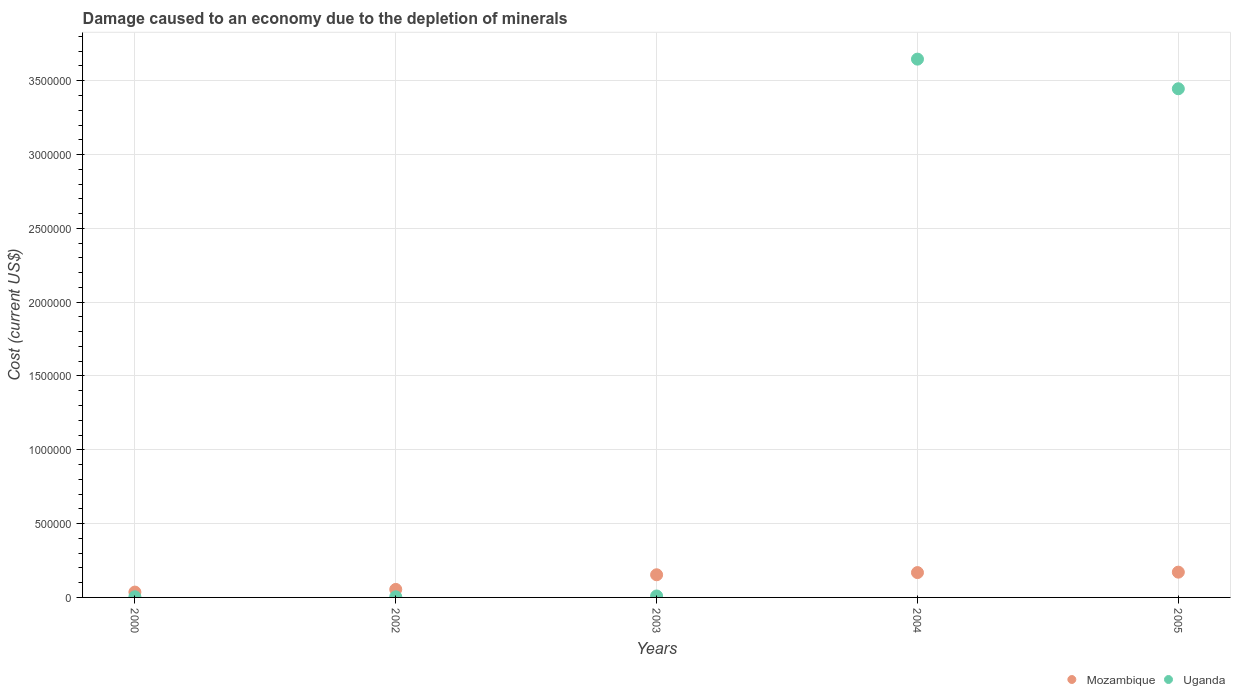Is the number of dotlines equal to the number of legend labels?
Ensure brevity in your answer.  Yes. What is the cost of damage caused due to the depletion of minerals in Uganda in 2005?
Give a very brief answer. 3.45e+06. Across all years, what is the maximum cost of damage caused due to the depletion of minerals in Uganda?
Ensure brevity in your answer.  3.65e+06. Across all years, what is the minimum cost of damage caused due to the depletion of minerals in Uganda?
Give a very brief answer. 4439.92. In which year was the cost of damage caused due to the depletion of minerals in Uganda minimum?
Offer a very short reply. 2002. What is the total cost of damage caused due to the depletion of minerals in Mozambique in the graph?
Offer a terse response. 5.83e+05. What is the difference between the cost of damage caused due to the depletion of minerals in Uganda in 2002 and that in 2005?
Offer a very short reply. -3.44e+06. What is the difference between the cost of damage caused due to the depletion of minerals in Mozambique in 2004 and the cost of damage caused due to the depletion of minerals in Uganda in 2000?
Make the answer very short. 1.64e+05. What is the average cost of damage caused due to the depletion of minerals in Mozambique per year?
Offer a very short reply. 1.17e+05. In the year 2002, what is the difference between the cost of damage caused due to the depletion of minerals in Mozambique and cost of damage caused due to the depletion of minerals in Uganda?
Provide a short and direct response. 4.99e+04. In how many years, is the cost of damage caused due to the depletion of minerals in Uganda greater than 2000000 US$?
Ensure brevity in your answer.  2. What is the ratio of the cost of damage caused due to the depletion of minerals in Mozambique in 2003 to that in 2005?
Offer a very short reply. 0.9. Is the difference between the cost of damage caused due to the depletion of minerals in Mozambique in 2000 and 2005 greater than the difference between the cost of damage caused due to the depletion of minerals in Uganda in 2000 and 2005?
Offer a terse response. Yes. What is the difference between the highest and the second highest cost of damage caused due to the depletion of minerals in Uganda?
Your answer should be very brief. 2.01e+05. What is the difference between the highest and the lowest cost of damage caused due to the depletion of minerals in Uganda?
Keep it short and to the point. 3.64e+06. Does the cost of damage caused due to the depletion of minerals in Mozambique monotonically increase over the years?
Offer a terse response. Yes. Is the cost of damage caused due to the depletion of minerals in Uganda strictly less than the cost of damage caused due to the depletion of minerals in Mozambique over the years?
Offer a very short reply. No. How many dotlines are there?
Your response must be concise. 2. How many years are there in the graph?
Offer a very short reply. 5. What is the difference between two consecutive major ticks on the Y-axis?
Offer a very short reply. 5.00e+05. Are the values on the major ticks of Y-axis written in scientific E-notation?
Provide a succinct answer. No. Does the graph contain any zero values?
Your answer should be very brief. No. Does the graph contain grids?
Give a very brief answer. Yes. Where does the legend appear in the graph?
Your answer should be very brief. Bottom right. How many legend labels are there?
Provide a succinct answer. 2. What is the title of the graph?
Ensure brevity in your answer.  Damage caused to an economy due to the depletion of minerals. What is the label or title of the X-axis?
Offer a terse response. Years. What is the label or title of the Y-axis?
Your response must be concise. Cost (current US$). What is the Cost (current US$) in Mozambique in 2000?
Your response must be concise. 3.62e+04. What is the Cost (current US$) of Uganda in 2000?
Provide a succinct answer. 4585.39. What is the Cost (current US$) in Mozambique in 2002?
Give a very brief answer. 5.43e+04. What is the Cost (current US$) of Uganda in 2002?
Provide a short and direct response. 4439.92. What is the Cost (current US$) of Mozambique in 2003?
Provide a succinct answer. 1.53e+05. What is the Cost (current US$) of Uganda in 2003?
Your answer should be compact. 9801.46. What is the Cost (current US$) in Mozambique in 2004?
Make the answer very short. 1.68e+05. What is the Cost (current US$) in Uganda in 2004?
Offer a very short reply. 3.65e+06. What is the Cost (current US$) in Mozambique in 2005?
Your answer should be very brief. 1.71e+05. What is the Cost (current US$) in Uganda in 2005?
Ensure brevity in your answer.  3.45e+06. Across all years, what is the maximum Cost (current US$) in Mozambique?
Keep it short and to the point. 1.71e+05. Across all years, what is the maximum Cost (current US$) of Uganda?
Provide a succinct answer. 3.65e+06. Across all years, what is the minimum Cost (current US$) in Mozambique?
Offer a terse response. 3.62e+04. Across all years, what is the minimum Cost (current US$) of Uganda?
Offer a terse response. 4439.92. What is the total Cost (current US$) of Mozambique in the graph?
Offer a very short reply. 5.83e+05. What is the total Cost (current US$) in Uganda in the graph?
Your response must be concise. 7.11e+06. What is the difference between the Cost (current US$) of Mozambique in 2000 and that in 2002?
Ensure brevity in your answer.  -1.81e+04. What is the difference between the Cost (current US$) in Uganda in 2000 and that in 2002?
Your answer should be very brief. 145.46. What is the difference between the Cost (current US$) of Mozambique in 2000 and that in 2003?
Offer a terse response. -1.17e+05. What is the difference between the Cost (current US$) of Uganda in 2000 and that in 2003?
Provide a short and direct response. -5216.07. What is the difference between the Cost (current US$) in Mozambique in 2000 and that in 2004?
Provide a short and direct response. -1.32e+05. What is the difference between the Cost (current US$) in Uganda in 2000 and that in 2004?
Give a very brief answer. -3.64e+06. What is the difference between the Cost (current US$) in Mozambique in 2000 and that in 2005?
Your answer should be very brief. -1.35e+05. What is the difference between the Cost (current US$) in Uganda in 2000 and that in 2005?
Offer a terse response. -3.44e+06. What is the difference between the Cost (current US$) in Mozambique in 2002 and that in 2003?
Ensure brevity in your answer.  -9.91e+04. What is the difference between the Cost (current US$) of Uganda in 2002 and that in 2003?
Keep it short and to the point. -5361.53. What is the difference between the Cost (current US$) of Mozambique in 2002 and that in 2004?
Offer a terse response. -1.14e+05. What is the difference between the Cost (current US$) of Uganda in 2002 and that in 2004?
Give a very brief answer. -3.64e+06. What is the difference between the Cost (current US$) in Mozambique in 2002 and that in 2005?
Keep it short and to the point. -1.17e+05. What is the difference between the Cost (current US$) of Uganda in 2002 and that in 2005?
Ensure brevity in your answer.  -3.44e+06. What is the difference between the Cost (current US$) of Mozambique in 2003 and that in 2004?
Offer a very short reply. -1.48e+04. What is the difference between the Cost (current US$) in Uganda in 2003 and that in 2004?
Offer a terse response. -3.64e+06. What is the difference between the Cost (current US$) of Mozambique in 2003 and that in 2005?
Provide a short and direct response. -1.77e+04. What is the difference between the Cost (current US$) in Uganda in 2003 and that in 2005?
Offer a very short reply. -3.44e+06. What is the difference between the Cost (current US$) in Mozambique in 2004 and that in 2005?
Give a very brief answer. -2931.99. What is the difference between the Cost (current US$) in Uganda in 2004 and that in 2005?
Make the answer very short. 2.01e+05. What is the difference between the Cost (current US$) in Mozambique in 2000 and the Cost (current US$) in Uganda in 2002?
Your answer should be very brief. 3.18e+04. What is the difference between the Cost (current US$) of Mozambique in 2000 and the Cost (current US$) of Uganda in 2003?
Your answer should be very brief. 2.64e+04. What is the difference between the Cost (current US$) in Mozambique in 2000 and the Cost (current US$) in Uganda in 2004?
Give a very brief answer. -3.61e+06. What is the difference between the Cost (current US$) of Mozambique in 2000 and the Cost (current US$) of Uganda in 2005?
Ensure brevity in your answer.  -3.41e+06. What is the difference between the Cost (current US$) of Mozambique in 2002 and the Cost (current US$) of Uganda in 2003?
Give a very brief answer. 4.45e+04. What is the difference between the Cost (current US$) in Mozambique in 2002 and the Cost (current US$) in Uganda in 2004?
Your answer should be very brief. -3.59e+06. What is the difference between the Cost (current US$) in Mozambique in 2002 and the Cost (current US$) in Uganda in 2005?
Provide a short and direct response. -3.39e+06. What is the difference between the Cost (current US$) of Mozambique in 2003 and the Cost (current US$) of Uganda in 2004?
Give a very brief answer. -3.49e+06. What is the difference between the Cost (current US$) of Mozambique in 2003 and the Cost (current US$) of Uganda in 2005?
Ensure brevity in your answer.  -3.29e+06. What is the difference between the Cost (current US$) of Mozambique in 2004 and the Cost (current US$) of Uganda in 2005?
Provide a short and direct response. -3.28e+06. What is the average Cost (current US$) in Mozambique per year?
Offer a very short reply. 1.17e+05. What is the average Cost (current US$) in Uganda per year?
Ensure brevity in your answer.  1.42e+06. In the year 2000, what is the difference between the Cost (current US$) in Mozambique and Cost (current US$) in Uganda?
Provide a succinct answer. 3.16e+04. In the year 2002, what is the difference between the Cost (current US$) of Mozambique and Cost (current US$) of Uganda?
Offer a very short reply. 4.99e+04. In the year 2003, what is the difference between the Cost (current US$) in Mozambique and Cost (current US$) in Uganda?
Your answer should be compact. 1.44e+05. In the year 2004, what is the difference between the Cost (current US$) in Mozambique and Cost (current US$) in Uganda?
Ensure brevity in your answer.  -3.48e+06. In the year 2005, what is the difference between the Cost (current US$) of Mozambique and Cost (current US$) of Uganda?
Provide a succinct answer. -3.27e+06. What is the ratio of the Cost (current US$) in Mozambique in 2000 to that in 2002?
Your response must be concise. 0.67. What is the ratio of the Cost (current US$) of Uganda in 2000 to that in 2002?
Offer a terse response. 1.03. What is the ratio of the Cost (current US$) of Mozambique in 2000 to that in 2003?
Ensure brevity in your answer.  0.24. What is the ratio of the Cost (current US$) in Uganda in 2000 to that in 2003?
Ensure brevity in your answer.  0.47. What is the ratio of the Cost (current US$) of Mozambique in 2000 to that in 2004?
Provide a short and direct response. 0.22. What is the ratio of the Cost (current US$) in Uganda in 2000 to that in 2004?
Ensure brevity in your answer.  0. What is the ratio of the Cost (current US$) in Mozambique in 2000 to that in 2005?
Your answer should be very brief. 0.21. What is the ratio of the Cost (current US$) in Uganda in 2000 to that in 2005?
Ensure brevity in your answer.  0. What is the ratio of the Cost (current US$) in Mozambique in 2002 to that in 2003?
Offer a terse response. 0.35. What is the ratio of the Cost (current US$) in Uganda in 2002 to that in 2003?
Offer a very short reply. 0.45. What is the ratio of the Cost (current US$) of Mozambique in 2002 to that in 2004?
Your answer should be very brief. 0.32. What is the ratio of the Cost (current US$) in Uganda in 2002 to that in 2004?
Your answer should be compact. 0. What is the ratio of the Cost (current US$) of Mozambique in 2002 to that in 2005?
Offer a very short reply. 0.32. What is the ratio of the Cost (current US$) in Uganda in 2002 to that in 2005?
Your answer should be compact. 0. What is the ratio of the Cost (current US$) of Mozambique in 2003 to that in 2004?
Keep it short and to the point. 0.91. What is the ratio of the Cost (current US$) in Uganda in 2003 to that in 2004?
Provide a short and direct response. 0. What is the ratio of the Cost (current US$) of Mozambique in 2003 to that in 2005?
Ensure brevity in your answer.  0.9. What is the ratio of the Cost (current US$) of Uganda in 2003 to that in 2005?
Your answer should be compact. 0. What is the ratio of the Cost (current US$) of Mozambique in 2004 to that in 2005?
Provide a succinct answer. 0.98. What is the ratio of the Cost (current US$) in Uganda in 2004 to that in 2005?
Your answer should be compact. 1.06. What is the difference between the highest and the second highest Cost (current US$) of Mozambique?
Provide a succinct answer. 2931.99. What is the difference between the highest and the second highest Cost (current US$) of Uganda?
Make the answer very short. 2.01e+05. What is the difference between the highest and the lowest Cost (current US$) in Mozambique?
Provide a short and direct response. 1.35e+05. What is the difference between the highest and the lowest Cost (current US$) in Uganda?
Give a very brief answer. 3.64e+06. 